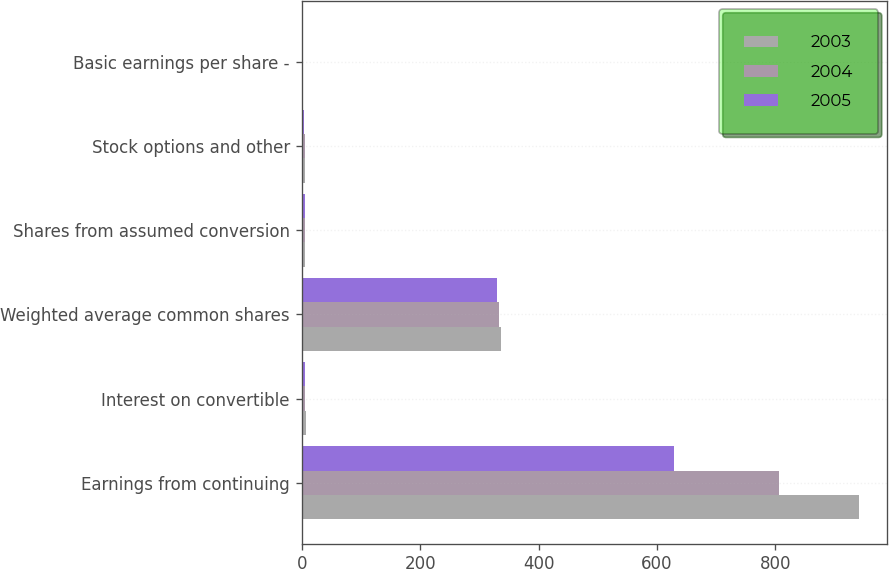<chart> <loc_0><loc_0><loc_500><loc_500><stacked_bar_chart><ecel><fcel>Earnings from continuing<fcel>Interest on convertible<fcel>Weighted average common shares<fcel>Shares from assumed conversion<fcel>Stock options and other<fcel>Basic earnings per share -<nl><fcel>2003<fcel>941<fcel>7<fcel>336.6<fcel>5.8<fcel>4.9<fcel>2.87<nl><fcel>2004<fcel>806<fcel>6<fcel>333.9<fcel>5.8<fcel>4.8<fcel>2.47<nl><fcel>2005<fcel>628<fcel>6<fcel>330.7<fcel>5.8<fcel>3.8<fcel>1.93<nl></chart> 